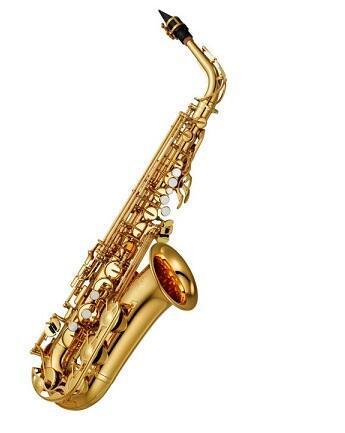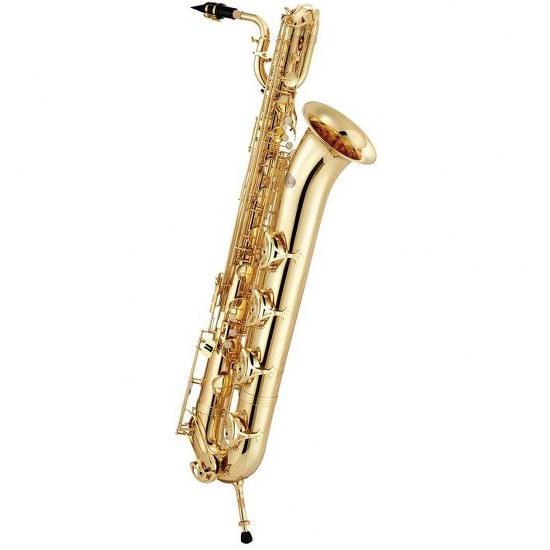The first image is the image on the left, the second image is the image on the right. Analyze the images presented: Is the assertion "One saxophone is displayed vertically, and the other is displayed at an angle with the bell-side upturned and the mouthpiece at the upper left." valid? Answer yes or no. No. The first image is the image on the left, the second image is the image on the right. Considering the images on both sides, is "The saxophone on the left is standing straight up and down." valid? Answer yes or no. No. 